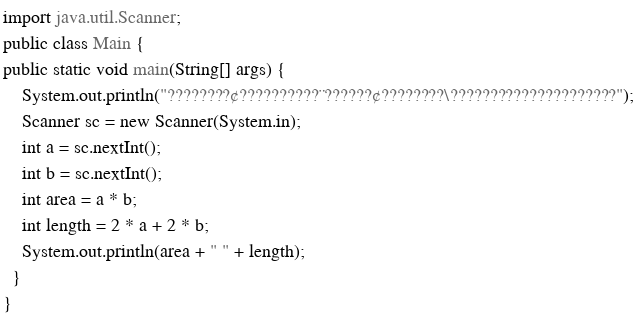<code> <loc_0><loc_0><loc_500><loc_500><_Java_>import java.util.Scanner;
public class Main {
public static void main(String[] args) {
	System.out.println("????????¢??????????¨??????¢????????\?????????????????????");
    Scanner sc = new Scanner(System.in);
    int a = sc.nextInt();
    int b = sc.nextInt();
    int area = a * b;
    int length = 2 * a + 2 * b; 
    System.out.println(area + " " + length);
  }
}</code> 